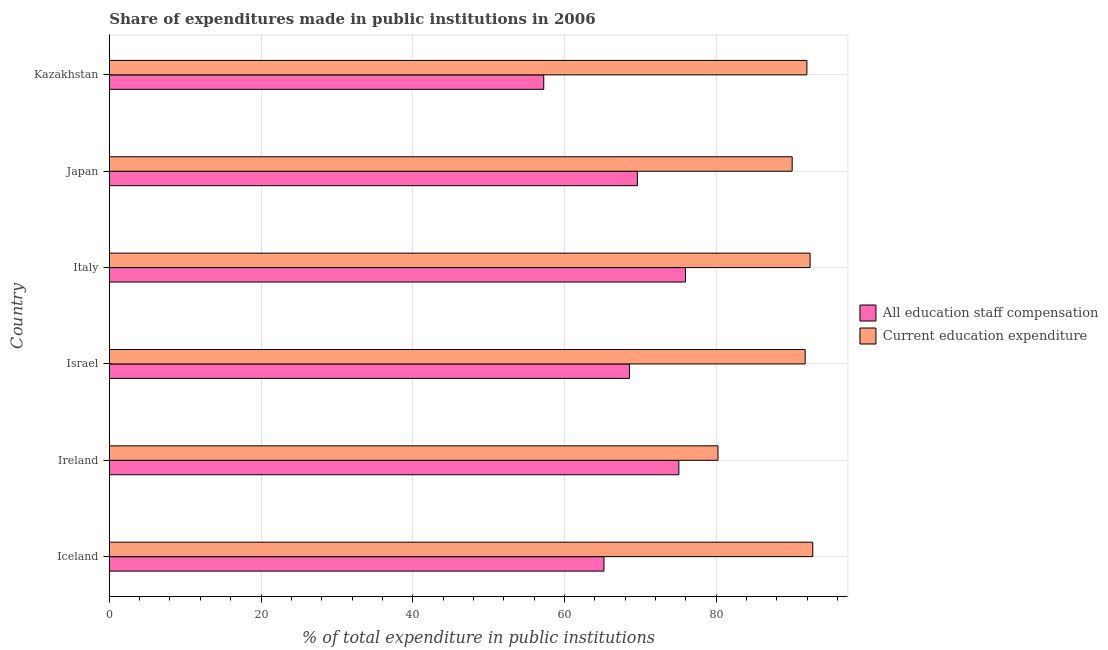How many groups of bars are there?
Make the answer very short. 6. How many bars are there on the 2nd tick from the bottom?
Your answer should be compact. 2. What is the label of the 1st group of bars from the top?
Offer a very short reply. Kazakhstan. What is the expenditure in education in Japan?
Your response must be concise. 90.01. Across all countries, what is the maximum expenditure in staff compensation?
Give a very brief answer. 75.95. Across all countries, what is the minimum expenditure in staff compensation?
Your answer should be very brief. 57.27. In which country was the expenditure in staff compensation maximum?
Offer a terse response. Italy. In which country was the expenditure in education minimum?
Offer a terse response. Ireland. What is the total expenditure in staff compensation in the graph?
Provide a short and direct response. 411.66. What is the difference between the expenditure in education in Ireland and that in Japan?
Make the answer very short. -9.78. What is the difference between the expenditure in staff compensation in Israel and the expenditure in education in Italy?
Ensure brevity in your answer.  -23.81. What is the average expenditure in staff compensation per country?
Give a very brief answer. 68.61. What is the difference between the expenditure in staff compensation and expenditure in education in Israel?
Ensure brevity in your answer.  -23.16. Is the difference between the expenditure in staff compensation in Iceland and Italy greater than the difference between the expenditure in education in Iceland and Italy?
Your answer should be very brief. No. What is the difference between the highest and the second highest expenditure in staff compensation?
Offer a terse response. 0.87. What is the difference between the highest and the lowest expenditure in staff compensation?
Provide a succinct answer. 18.69. Is the sum of the expenditure in staff compensation in Iceland and Kazakhstan greater than the maximum expenditure in education across all countries?
Keep it short and to the point. Yes. What does the 1st bar from the top in Ireland represents?
Offer a terse response. Current education expenditure. What does the 1st bar from the bottom in Ireland represents?
Your answer should be compact. All education staff compensation. How many bars are there?
Make the answer very short. 12. Are all the bars in the graph horizontal?
Your answer should be compact. Yes. What is the difference between two consecutive major ticks on the X-axis?
Make the answer very short. 20. Are the values on the major ticks of X-axis written in scientific E-notation?
Ensure brevity in your answer.  No. Does the graph contain grids?
Offer a very short reply. Yes. How are the legend labels stacked?
Your answer should be very brief. Vertical. What is the title of the graph?
Your answer should be very brief. Share of expenditures made in public institutions in 2006. What is the label or title of the X-axis?
Offer a terse response. % of total expenditure in public institutions. What is the label or title of the Y-axis?
Give a very brief answer. Country. What is the % of total expenditure in public institutions of All education staff compensation in Iceland?
Your answer should be compact. 65.2. What is the % of total expenditure in public institutions of Current education expenditure in Iceland?
Ensure brevity in your answer.  92.73. What is the % of total expenditure in public institutions of All education staff compensation in Ireland?
Your response must be concise. 75.08. What is the % of total expenditure in public institutions of Current education expenditure in Ireland?
Ensure brevity in your answer.  80.23. What is the % of total expenditure in public institutions in All education staff compensation in Israel?
Your answer should be compact. 68.56. What is the % of total expenditure in public institutions in Current education expenditure in Israel?
Offer a very short reply. 91.73. What is the % of total expenditure in public institutions of All education staff compensation in Italy?
Ensure brevity in your answer.  75.95. What is the % of total expenditure in public institutions in Current education expenditure in Italy?
Provide a succinct answer. 92.37. What is the % of total expenditure in public institutions in All education staff compensation in Japan?
Give a very brief answer. 69.61. What is the % of total expenditure in public institutions in Current education expenditure in Japan?
Ensure brevity in your answer.  90.01. What is the % of total expenditure in public institutions of All education staff compensation in Kazakhstan?
Ensure brevity in your answer.  57.27. What is the % of total expenditure in public institutions in Current education expenditure in Kazakhstan?
Keep it short and to the point. 91.95. Across all countries, what is the maximum % of total expenditure in public institutions in All education staff compensation?
Give a very brief answer. 75.95. Across all countries, what is the maximum % of total expenditure in public institutions of Current education expenditure?
Give a very brief answer. 92.73. Across all countries, what is the minimum % of total expenditure in public institutions in All education staff compensation?
Your response must be concise. 57.27. Across all countries, what is the minimum % of total expenditure in public institutions of Current education expenditure?
Ensure brevity in your answer.  80.23. What is the total % of total expenditure in public institutions in All education staff compensation in the graph?
Your answer should be compact. 411.66. What is the total % of total expenditure in public institutions in Current education expenditure in the graph?
Provide a succinct answer. 539.03. What is the difference between the % of total expenditure in public institutions of All education staff compensation in Iceland and that in Ireland?
Keep it short and to the point. -9.87. What is the difference between the % of total expenditure in public institutions in Current education expenditure in Iceland and that in Ireland?
Your answer should be compact. 12.49. What is the difference between the % of total expenditure in public institutions of All education staff compensation in Iceland and that in Israel?
Your answer should be compact. -3.36. What is the difference between the % of total expenditure in public institutions in All education staff compensation in Iceland and that in Italy?
Offer a terse response. -10.75. What is the difference between the % of total expenditure in public institutions of Current education expenditure in Iceland and that in Italy?
Make the answer very short. 0.35. What is the difference between the % of total expenditure in public institutions in All education staff compensation in Iceland and that in Japan?
Give a very brief answer. -4.4. What is the difference between the % of total expenditure in public institutions in Current education expenditure in Iceland and that in Japan?
Your answer should be very brief. 2.72. What is the difference between the % of total expenditure in public institutions of All education staff compensation in Iceland and that in Kazakhstan?
Give a very brief answer. 7.94. What is the difference between the % of total expenditure in public institutions of Current education expenditure in Iceland and that in Kazakhstan?
Your response must be concise. 0.78. What is the difference between the % of total expenditure in public institutions of All education staff compensation in Ireland and that in Israel?
Ensure brevity in your answer.  6.51. What is the difference between the % of total expenditure in public institutions in Current education expenditure in Ireland and that in Israel?
Provide a succinct answer. -11.49. What is the difference between the % of total expenditure in public institutions in All education staff compensation in Ireland and that in Italy?
Your response must be concise. -0.87. What is the difference between the % of total expenditure in public institutions in Current education expenditure in Ireland and that in Italy?
Offer a very short reply. -12.14. What is the difference between the % of total expenditure in public institutions in All education staff compensation in Ireland and that in Japan?
Your answer should be very brief. 5.47. What is the difference between the % of total expenditure in public institutions of Current education expenditure in Ireland and that in Japan?
Offer a very short reply. -9.78. What is the difference between the % of total expenditure in public institutions in All education staff compensation in Ireland and that in Kazakhstan?
Keep it short and to the point. 17.81. What is the difference between the % of total expenditure in public institutions of Current education expenditure in Ireland and that in Kazakhstan?
Offer a terse response. -11.72. What is the difference between the % of total expenditure in public institutions in All education staff compensation in Israel and that in Italy?
Keep it short and to the point. -7.39. What is the difference between the % of total expenditure in public institutions of Current education expenditure in Israel and that in Italy?
Make the answer very short. -0.65. What is the difference between the % of total expenditure in public institutions of All education staff compensation in Israel and that in Japan?
Give a very brief answer. -1.04. What is the difference between the % of total expenditure in public institutions in Current education expenditure in Israel and that in Japan?
Give a very brief answer. 1.72. What is the difference between the % of total expenditure in public institutions of All education staff compensation in Israel and that in Kazakhstan?
Your answer should be compact. 11.3. What is the difference between the % of total expenditure in public institutions in Current education expenditure in Israel and that in Kazakhstan?
Your answer should be very brief. -0.22. What is the difference between the % of total expenditure in public institutions in All education staff compensation in Italy and that in Japan?
Ensure brevity in your answer.  6.34. What is the difference between the % of total expenditure in public institutions of Current education expenditure in Italy and that in Japan?
Provide a succinct answer. 2.36. What is the difference between the % of total expenditure in public institutions in All education staff compensation in Italy and that in Kazakhstan?
Give a very brief answer. 18.69. What is the difference between the % of total expenditure in public institutions in Current education expenditure in Italy and that in Kazakhstan?
Make the answer very short. 0.42. What is the difference between the % of total expenditure in public institutions of All education staff compensation in Japan and that in Kazakhstan?
Ensure brevity in your answer.  12.34. What is the difference between the % of total expenditure in public institutions in Current education expenditure in Japan and that in Kazakhstan?
Give a very brief answer. -1.94. What is the difference between the % of total expenditure in public institutions in All education staff compensation in Iceland and the % of total expenditure in public institutions in Current education expenditure in Ireland?
Provide a short and direct response. -15.03. What is the difference between the % of total expenditure in public institutions of All education staff compensation in Iceland and the % of total expenditure in public institutions of Current education expenditure in Israel?
Your response must be concise. -26.52. What is the difference between the % of total expenditure in public institutions of All education staff compensation in Iceland and the % of total expenditure in public institutions of Current education expenditure in Italy?
Give a very brief answer. -27.17. What is the difference between the % of total expenditure in public institutions in All education staff compensation in Iceland and the % of total expenditure in public institutions in Current education expenditure in Japan?
Provide a short and direct response. -24.81. What is the difference between the % of total expenditure in public institutions of All education staff compensation in Iceland and the % of total expenditure in public institutions of Current education expenditure in Kazakhstan?
Give a very brief answer. -26.75. What is the difference between the % of total expenditure in public institutions in All education staff compensation in Ireland and the % of total expenditure in public institutions in Current education expenditure in Israel?
Keep it short and to the point. -16.65. What is the difference between the % of total expenditure in public institutions of All education staff compensation in Ireland and the % of total expenditure in public institutions of Current education expenditure in Italy?
Your answer should be very brief. -17.3. What is the difference between the % of total expenditure in public institutions of All education staff compensation in Ireland and the % of total expenditure in public institutions of Current education expenditure in Japan?
Offer a very short reply. -14.94. What is the difference between the % of total expenditure in public institutions of All education staff compensation in Ireland and the % of total expenditure in public institutions of Current education expenditure in Kazakhstan?
Your response must be concise. -16.88. What is the difference between the % of total expenditure in public institutions of All education staff compensation in Israel and the % of total expenditure in public institutions of Current education expenditure in Italy?
Your answer should be compact. -23.81. What is the difference between the % of total expenditure in public institutions of All education staff compensation in Israel and the % of total expenditure in public institutions of Current education expenditure in Japan?
Provide a short and direct response. -21.45. What is the difference between the % of total expenditure in public institutions of All education staff compensation in Israel and the % of total expenditure in public institutions of Current education expenditure in Kazakhstan?
Provide a succinct answer. -23.39. What is the difference between the % of total expenditure in public institutions in All education staff compensation in Italy and the % of total expenditure in public institutions in Current education expenditure in Japan?
Your answer should be compact. -14.06. What is the difference between the % of total expenditure in public institutions of All education staff compensation in Italy and the % of total expenditure in public institutions of Current education expenditure in Kazakhstan?
Offer a terse response. -16. What is the difference between the % of total expenditure in public institutions in All education staff compensation in Japan and the % of total expenditure in public institutions in Current education expenditure in Kazakhstan?
Make the answer very short. -22.35. What is the average % of total expenditure in public institutions of All education staff compensation per country?
Provide a short and direct response. 68.61. What is the average % of total expenditure in public institutions in Current education expenditure per country?
Your answer should be very brief. 89.84. What is the difference between the % of total expenditure in public institutions in All education staff compensation and % of total expenditure in public institutions in Current education expenditure in Iceland?
Provide a succinct answer. -27.52. What is the difference between the % of total expenditure in public institutions in All education staff compensation and % of total expenditure in public institutions in Current education expenditure in Ireland?
Your answer should be very brief. -5.16. What is the difference between the % of total expenditure in public institutions of All education staff compensation and % of total expenditure in public institutions of Current education expenditure in Israel?
Provide a succinct answer. -23.17. What is the difference between the % of total expenditure in public institutions of All education staff compensation and % of total expenditure in public institutions of Current education expenditure in Italy?
Provide a succinct answer. -16.42. What is the difference between the % of total expenditure in public institutions of All education staff compensation and % of total expenditure in public institutions of Current education expenditure in Japan?
Give a very brief answer. -20.41. What is the difference between the % of total expenditure in public institutions in All education staff compensation and % of total expenditure in public institutions in Current education expenditure in Kazakhstan?
Your answer should be very brief. -34.69. What is the ratio of the % of total expenditure in public institutions of All education staff compensation in Iceland to that in Ireland?
Give a very brief answer. 0.87. What is the ratio of the % of total expenditure in public institutions in Current education expenditure in Iceland to that in Ireland?
Ensure brevity in your answer.  1.16. What is the ratio of the % of total expenditure in public institutions of All education staff compensation in Iceland to that in Israel?
Provide a succinct answer. 0.95. What is the ratio of the % of total expenditure in public institutions of Current education expenditure in Iceland to that in Israel?
Give a very brief answer. 1.01. What is the ratio of the % of total expenditure in public institutions of All education staff compensation in Iceland to that in Italy?
Give a very brief answer. 0.86. What is the ratio of the % of total expenditure in public institutions of All education staff compensation in Iceland to that in Japan?
Provide a short and direct response. 0.94. What is the ratio of the % of total expenditure in public institutions in Current education expenditure in Iceland to that in Japan?
Your answer should be very brief. 1.03. What is the ratio of the % of total expenditure in public institutions in All education staff compensation in Iceland to that in Kazakhstan?
Keep it short and to the point. 1.14. What is the ratio of the % of total expenditure in public institutions in Current education expenditure in Iceland to that in Kazakhstan?
Provide a succinct answer. 1.01. What is the ratio of the % of total expenditure in public institutions of All education staff compensation in Ireland to that in Israel?
Make the answer very short. 1.09. What is the ratio of the % of total expenditure in public institutions of Current education expenditure in Ireland to that in Israel?
Give a very brief answer. 0.87. What is the ratio of the % of total expenditure in public institutions of Current education expenditure in Ireland to that in Italy?
Offer a terse response. 0.87. What is the ratio of the % of total expenditure in public institutions of All education staff compensation in Ireland to that in Japan?
Your answer should be very brief. 1.08. What is the ratio of the % of total expenditure in public institutions in Current education expenditure in Ireland to that in Japan?
Your answer should be compact. 0.89. What is the ratio of the % of total expenditure in public institutions in All education staff compensation in Ireland to that in Kazakhstan?
Offer a terse response. 1.31. What is the ratio of the % of total expenditure in public institutions of Current education expenditure in Ireland to that in Kazakhstan?
Provide a succinct answer. 0.87. What is the ratio of the % of total expenditure in public institutions of All education staff compensation in Israel to that in Italy?
Your response must be concise. 0.9. What is the ratio of the % of total expenditure in public institutions in Current education expenditure in Israel to that in Japan?
Keep it short and to the point. 1.02. What is the ratio of the % of total expenditure in public institutions in All education staff compensation in Israel to that in Kazakhstan?
Provide a succinct answer. 1.2. What is the ratio of the % of total expenditure in public institutions of All education staff compensation in Italy to that in Japan?
Keep it short and to the point. 1.09. What is the ratio of the % of total expenditure in public institutions of Current education expenditure in Italy to that in Japan?
Offer a terse response. 1.03. What is the ratio of the % of total expenditure in public institutions in All education staff compensation in Italy to that in Kazakhstan?
Your answer should be compact. 1.33. What is the ratio of the % of total expenditure in public institutions in All education staff compensation in Japan to that in Kazakhstan?
Your answer should be compact. 1.22. What is the ratio of the % of total expenditure in public institutions in Current education expenditure in Japan to that in Kazakhstan?
Your answer should be compact. 0.98. What is the difference between the highest and the second highest % of total expenditure in public institutions of All education staff compensation?
Your answer should be compact. 0.87. What is the difference between the highest and the second highest % of total expenditure in public institutions in Current education expenditure?
Your answer should be very brief. 0.35. What is the difference between the highest and the lowest % of total expenditure in public institutions in All education staff compensation?
Your answer should be compact. 18.69. What is the difference between the highest and the lowest % of total expenditure in public institutions of Current education expenditure?
Ensure brevity in your answer.  12.49. 